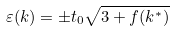<formula> <loc_0><loc_0><loc_500><loc_500>\varepsilon ( k ) = \pm t _ { 0 } \sqrt { 3 + f ( k ^ { * } ) }</formula> 